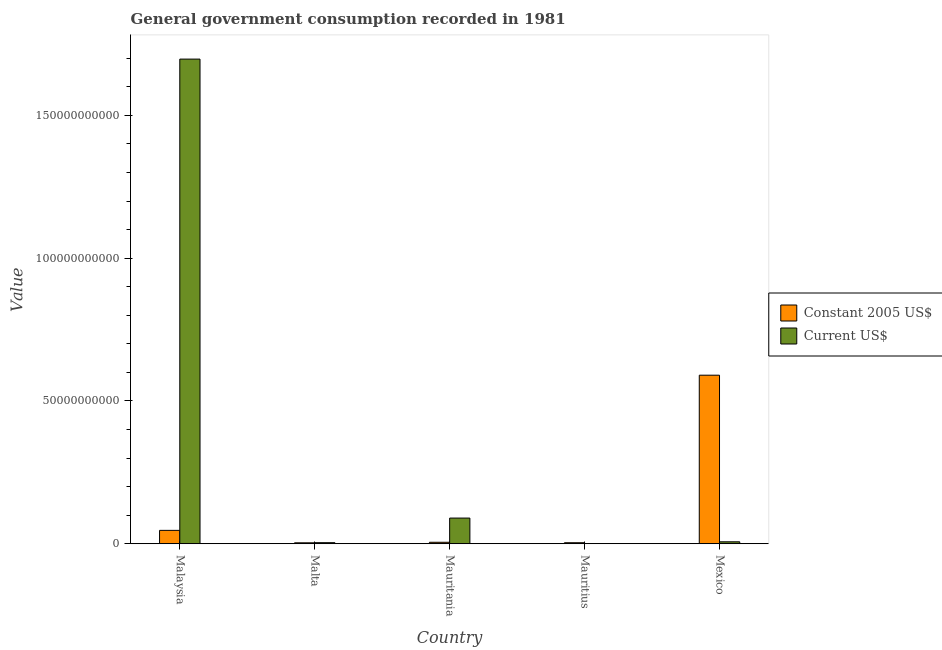How many different coloured bars are there?
Provide a short and direct response. 2. How many groups of bars are there?
Make the answer very short. 5. Are the number of bars per tick equal to the number of legend labels?
Offer a very short reply. Yes. Are the number of bars on each tick of the X-axis equal?
Ensure brevity in your answer.  Yes. How many bars are there on the 5th tick from the right?
Ensure brevity in your answer.  2. What is the label of the 3rd group of bars from the left?
Your response must be concise. Mauritania. What is the value consumed in constant 2005 us$ in Mauritania?
Keep it short and to the point. 5.17e+08. Across all countries, what is the maximum value consumed in constant 2005 us$?
Give a very brief answer. 5.90e+1. Across all countries, what is the minimum value consumed in current us$?
Keep it short and to the point. 1.77e+07. In which country was the value consumed in constant 2005 us$ maximum?
Ensure brevity in your answer.  Mexico. In which country was the value consumed in current us$ minimum?
Provide a succinct answer. Mauritius. What is the total value consumed in constant 2005 us$ in the graph?
Give a very brief answer. 6.49e+1. What is the difference between the value consumed in current us$ in Malaysia and that in Mexico?
Provide a succinct answer. 1.69e+11. What is the difference between the value consumed in constant 2005 us$ in Mexico and the value consumed in current us$ in Malaysia?
Keep it short and to the point. -1.11e+11. What is the average value consumed in constant 2005 us$ per country?
Keep it short and to the point. 1.30e+1. What is the difference between the value consumed in constant 2005 us$ and value consumed in current us$ in Mexico?
Your response must be concise. 5.83e+1. In how many countries, is the value consumed in constant 2005 us$ greater than 80000000000 ?
Give a very brief answer. 0. What is the ratio of the value consumed in constant 2005 us$ in Mauritius to that in Mexico?
Provide a succinct answer. 0.01. Is the value consumed in constant 2005 us$ in Malta less than that in Mexico?
Your answer should be compact. Yes. Is the difference between the value consumed in current us$ in Malta and Mauritania greater than the difference between the value consumed in constant 2005 us$ in Malta and Mauritania?
Offer a terse response. No. What is the difference between the highest and the second highest value consumed in constant 2005 us$?
Your answer should be compact. 5.43e+1. What is the difference between the highest and the lowest value consumed in constant 2005 us$?
Give a very brief answer. 5.87e+1. Is the sum of the value consumed in constant 2005 us$ in Mauritius and Mexico greater than the maximum value consumed in current us$ across all countries?
Make the answer very short. No. What does the 2nd bar from the left in Mexico represents?
Provide a short and direct response. Current US$. What does the 1st bar from the right in Mauritania represents?
Offer a very short reply. Current US$. How many bars are there?
Provide a succinct answer. 10. Are all the bars in the graph horizontal?
Give a very brief answer. No. Where does the legend appear in the graph?
Provide a succinct answer. Center right. How are the legend labels stacked?
Your answer should be very brief. Vertical. What is the title of the graph?
Provide a short and direct response. General government consumption recorded in 1981. Does "GDP per capita" appear as one of the legend labels in the graph?
Offer a very short reply. No. What is the label or title of the X-axis?
Make the answer very short. Country. What is the label or title of the Y-axis?
Offer a very short reply. Value. What is the Value in Constant 2005 US$ in Malaysia?
Your answer should be compact. 4.69e+09. What is the Value in Current US$ in Malaysia?
Your response must be concise. 1.70e+11. What is the Value of Constant 2005 US$ in Malta?
Your answer should be very brief. 3.31e+08. What is the Value of Current US$ in Malta?
Offer a terse response. 3.71e+08. What is the Value in Constant 2005 US$ in Mauritania?
Offer a very short reply. 5.17e+08. What is the Value of Current US$ in Mauritania?
Your answer should be very brief. 8.99e+09. What is the Value of Constant 2005 US$ in Mauritius?
Give a very brief answer. 3.59e+08. What is the Value of Current US$ in Mauritius?
Offer a terse response. 1.77e+07. What is the Value in Constant 2005 US$ in Mexico?
Offer a terse response. 5.90e+1. What is the Value in Current US$ in Mexico?
Your answer should be compact. 6.80e+08. Across all countries, what is the maximum Value in Constant 2005 US$?
Give a very brief answer. 5.90e+1. Across all countries, what is the maximum Value in Current US$?
Keep it short and to the point. 1.70e+11. Across all countries, what is the minimum Value in Constant 2005 US$?
Provide a short and direct response. 3.31e+08. Across all countries, what is the minimum Value in Current US$?
Offer a terse response. 1.77e+07. What is the total Value in Constant 2005 US$ in the graph?
Offer a very short reply. 6.49e+1. What is the total Value in Current US$ in the graph?
Ensure brevity in your answer.  1.80e+11. What is the difference between the Value of Constant 2005 US$ in Malaysia and that in Malta?
Keep it short and to the point. 4.36e+09. What is the difference between the Value in Current US$ in Malaysia and that in Malta?
Make the answer very short. 1.69e+11. What is the difference between the Value of Constant 2005 US$ in Malaysia and that in Mauritania?
Your answer should be compact. 4.17e+09. What is the difference between the Value in Current US$ in Malaysia and that in Mauritania?
Provide a short and direct response. 1.61e+11. What is the difference between the Value of Constant 2005 US$ in Malaysia and that in Mauritius?
Keep it short and to the point. 4.33e+09. What is the difference between the Value of Current US$ in Malaysia and that in Mauritius?
Ensure brevity in your answer.  1.70e+11. What is the difference between the Value in Constant 2005 US$ in Malaysia and that in Mexico?
Your response must be concise. -5.43e+1. What is the difference between the Value of Current US$ in Malaysia and that in Mexico?
Provide a succinct answer. 1.69e+11. What is the difference between the Value of Constant 2005 US$ in Malta and that in Mauritania?
Offer a very short reply. -1.86e+08. What is the difference between the Value of Current US$ in Malta and that in Mauritania?
Your response must be concise. -8.62e+09. What is the difference between the Value of Constant 2005 US$ in Malta and that in Mauritius?
Keep it short and to the point. -2.77e+07. What is the difference between the Value of Current US$ in Malta and that in Mauritius?
Give a very brief answer. 3.53e+08. What is the difference between the Value in Constant 2005 US$ in Malta and that in Mexico?
Your answer should be compact. -5.87e+1. What is the difference between the Value in Current US$ in Malta and that in Mexico?
Make the answer very short. -3.09e+08. What is the difference between the Value of Constant 2005 US$ in Mauritania and that in Mauritius?
Ensure brevity in your answer.  1.58e+08. What is the difference between the Value in Current US$ in Mauritania and that in Mauritius?
Give a very brief answer. 8.97e+09. What is the difference between the Value in Constant 2005 US$ in Mauritania and that in Mexico?
Make the answer very short. -5.85e+1. What is the difference between the Value in Current US$ in Mauritania and that in Mexico?
Your answer should be very brief. 8.31e+09. What is the difference between the Value of Constant 2005 US$ in Mauritius and that in Mexico?
Ensure brevity in your answer.  -5.87e+1. What is the difference between the Value of Current US$ in Mauritius and that in Mexico?
Give a very brief answer. -6.62e+08. What is the difference between the Value in Constant 2005 US$ in Malaysia and the Value in Current US$ in Malta?
Give a very brief answer. 4.32e+09. What is the difference between the Value of Constant 2005 US$ in Malaysia and the Value of Current US$ in Mauritania?
Provide a succinct answer. -4.30e+09. What is the difference between the Value in Constant 2005 US$ in Malaysia and the Value in Current US$ in Mauritius?
Provide a succinct answer. 4.67e+09. What is the difference between the Value in Constant 2005 US$ in Malaysia and the Value in Current US$ in Mexico?
Your answer should be very brief. 4.01e+09. What is the difference between the Value of Constant 2005 US$ in Malta and the Value of Current US$ in Mauritania?
Keep it short and to the point. -8.66e+09. What is the difference between the Value in Constant 2005 US$ in Malta and the Value in Current US$ in Mauritius?
Your response must be concise. 3.13e+08. What is the difference between the Value of Constant 2005 US$ in Malta and the Value of Current US$ in Mexico?
Make the answer very short. -3.49e+08. What is the difference between the Value in Constant 2005 US$ in Mauritania and the Value in Current US$ in Mauritius?
Make the answer very short. 4.99e+08. What is the difference between the Value in Constant 2005 US$ in Mauritania and the Value in Current US$ in Mexico?
Provide a succinct answer. -1.63e+08. What is the difference between the Value of Constant 2005 US$ in Mauritius and the Value of Current US$ in Mexico?
Provide a short and direct response. -3.21e+08. What is the average Value in Constant 2005 US$ per country?
Keep it short and to the point. 1.30e+1. What is the average Value of Current US$ per country?
Keep it short and to the point. 3.59e+1. What is the difference between the Value of Constant 2005 US$ and Value of Current US$ in Malaysia?
Make the answer very short. -1.65e+11. What is the difference between the Value of Constant 2005 US$ and Value of Current US$ in Malta?
Ensure brevity in your answer.  -4.03e+07. What is the difference between the Value of Constant 2005 US$ and Value of Current US$ in Mauritania?
Make the answer very short. -8.47e+09. What is the difference between the Value of Constant 2005 US$ and Value of Current US$ in Mauritius?
Provide a short and direct response. 3.41e+08. What is the difference between the Value in Constant 2005 US$ and Value in Current US$ in Mexico?
Provide a succinct answer. 5.83e+1. What is the ratio of the Value in Constant 2005 US$ in Malaysia to that in Malta?
Offer a very short reply. 14.17. What is the ratio of the Value in Current US$ in Malaysia to that in Malta?
Make the answer very short. 457.17. What is the ratio of the Value of Constant 2005 US$ in Malaysia to that in Mauritania?
Make the answer very short. 9.07. What is the ratio of the Value of Current US$ in Malaysia to that in Mauritania?
Make the answer very short. 18.87. What is the ratio of the Value of Constant 2005 US$ in Malaysia to that in Mauritius?
Make the answer very short. 13.07. What is the ratio of the Value of Current US$ in Malaysia to that in Mauritius?
Your answer should be compact. 9588.8. What is the ratio of the Value in Constant 2005 US$ in Malaysia to that in Mexico?
Offer a very short reply. 0.08. What is the ratio of the Value of Current US$ in Malaysia to that in Mexico?
Offer a terse response. 249.54. What is the ratio of the Value of Constant 2005 US$ in Malta to that in Mauritania?
Offer a very short reply. 0.64. What is the ratio of the Value of Current US$ in Malta to that in Mauritania?
Provide a short and direct response. 0.04. What is the ratio of the Value of Constant 2005 US$ in Malta to that in Mauritius?
Ensure brevity in your answer.  0.92. What is the ratio of the Value in Current US$ in Malta to that in Mauritius?
Provide a succinct answer. 20.97. What is the ratio of the Value in Constant 2005 US$ in Malta to that in Mexico?
Your response must be concise. 0.01. What is the ratio of the Value in Current US$ in Malta to that in Mexico?
Provide a short and direct response. 0.55. What is the ratio of the Value in Constant 2005 US$ in Mauritania to that in Mauritius?
Your response must be concise. 1.44. What is the ratio of the Value of Current US$ in Mauritania to that in Mauritius?
Ensure brevity in your answer.  508.09. What is the ratio of the Value in Constant 2005 US$ in Mauritania to that in Mexico?
Your answer should be very brief. 0.01. What is the ratio of the Value of Current US$ in Mauritania to that in Mexico?
Provide a short and direct response. 13.22. What is the ratio of the Value in Constant 2005 US$ in Mauritius to that in Mexico?
Make the answer very short. 0.01. What is the ratio of the Value of Current US$ in Mauritius to that in Mexico?
Your answer should be very brief. 0.03. What is the difference between the highest and the second highest Value of Constant 2005 US$?
Give a very brief answer. 5.43e+1. What is the difference between the highest and the second highest Value in Current US$?
Provide a short and direct response. 1.61e+11. What is the difference between the highest and the lowest Value in Constant 2005 US$?
Make the answer very short. 5.87e+1. What is the difference between the highest and the lowest Value of Current US$?
Give a very brief answer. 1.70e+11. 